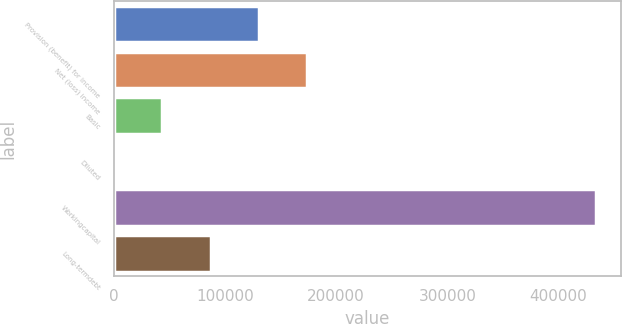Convert chart. <chart><loc_0><loc_0><loc_500><loc_500><bar_chart><fcel>Provision (benefit) for income<fcel>Net (loss) income<fcel>Basic<fcel>Diluted<fcel>Workingcapital<fcel>Long-termdebt<nl><fcel>130275<fcel>173699<fcel>43425.6<fcel>0.95<fcel>434247<fcel>86850.2<nl></chart> 